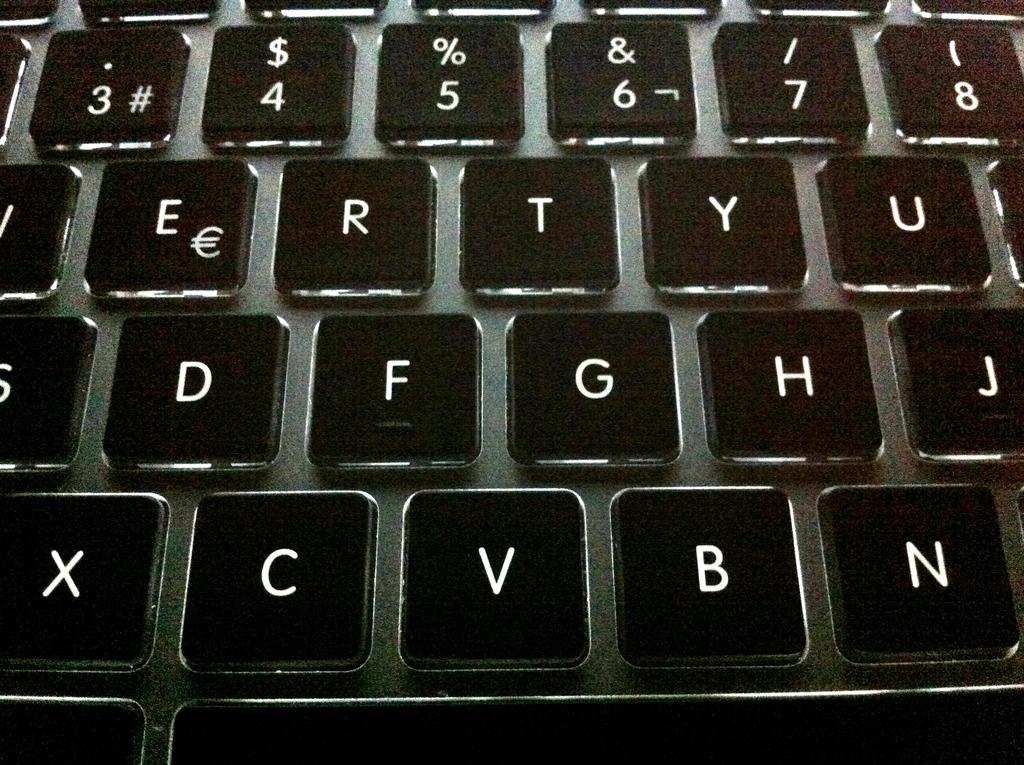<image>
Share a concise interpretation of the image provided. Black keyboard with the key F between the keys D and G. 